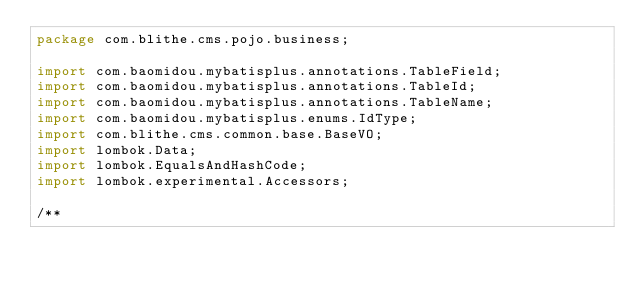Convert code to text. <code><loc_0><loc_0><loc_500><loc_500><_Java_>package com.blithe.cms.pojo.business;

import com.baomidou.mybatisplus.annotations.TableField;
import com.baomidou.mybatisplus.annotations.TableId;
import com.baomidou.mybatisplus.annotations.TableName;
import com.baomidou.mybatisplus.enums.IdType;
import com.blithe.cms.common.base.BaseVO;
import lombok.Data;
import lombok.EqualsAndHashCode;
import lombok.experimental.Accessors;

/**</code> 